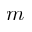Convert formula to latex. <formula><loc_0><loc_0><loc_500><loc_500>m</formula> 